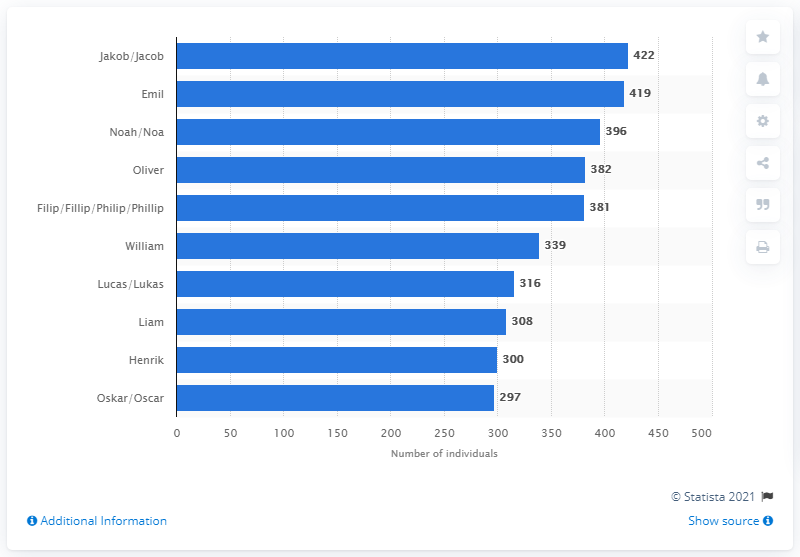Highlight a few significant elements in this photo. In 2020, a total of 422 baby boys were named Jakob. 